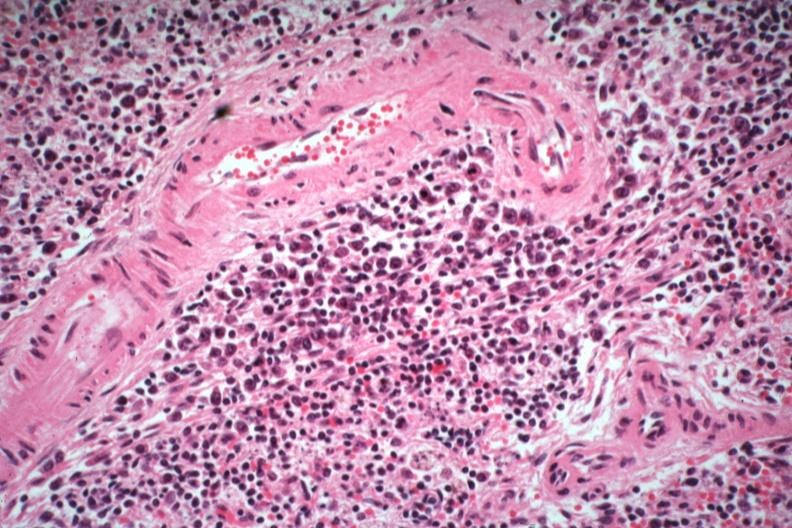what died of what was thought to be viral pneumonia probably influenza?
Answer the question using a single word or phrase. Numerous atypical cells around splenic arteriole man 